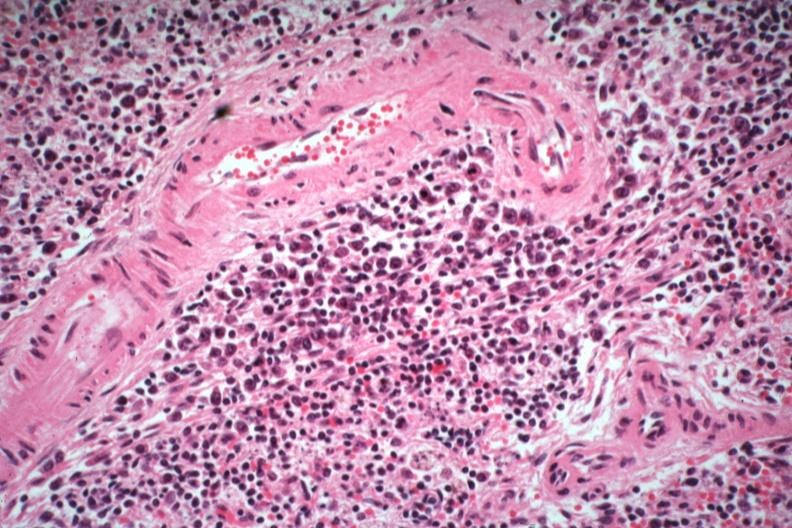what died of what was thought to be viral pneumonia probably influenza?
Answer the question using a single word or phrase. Numerous atypical cells around splenic arteriole man 